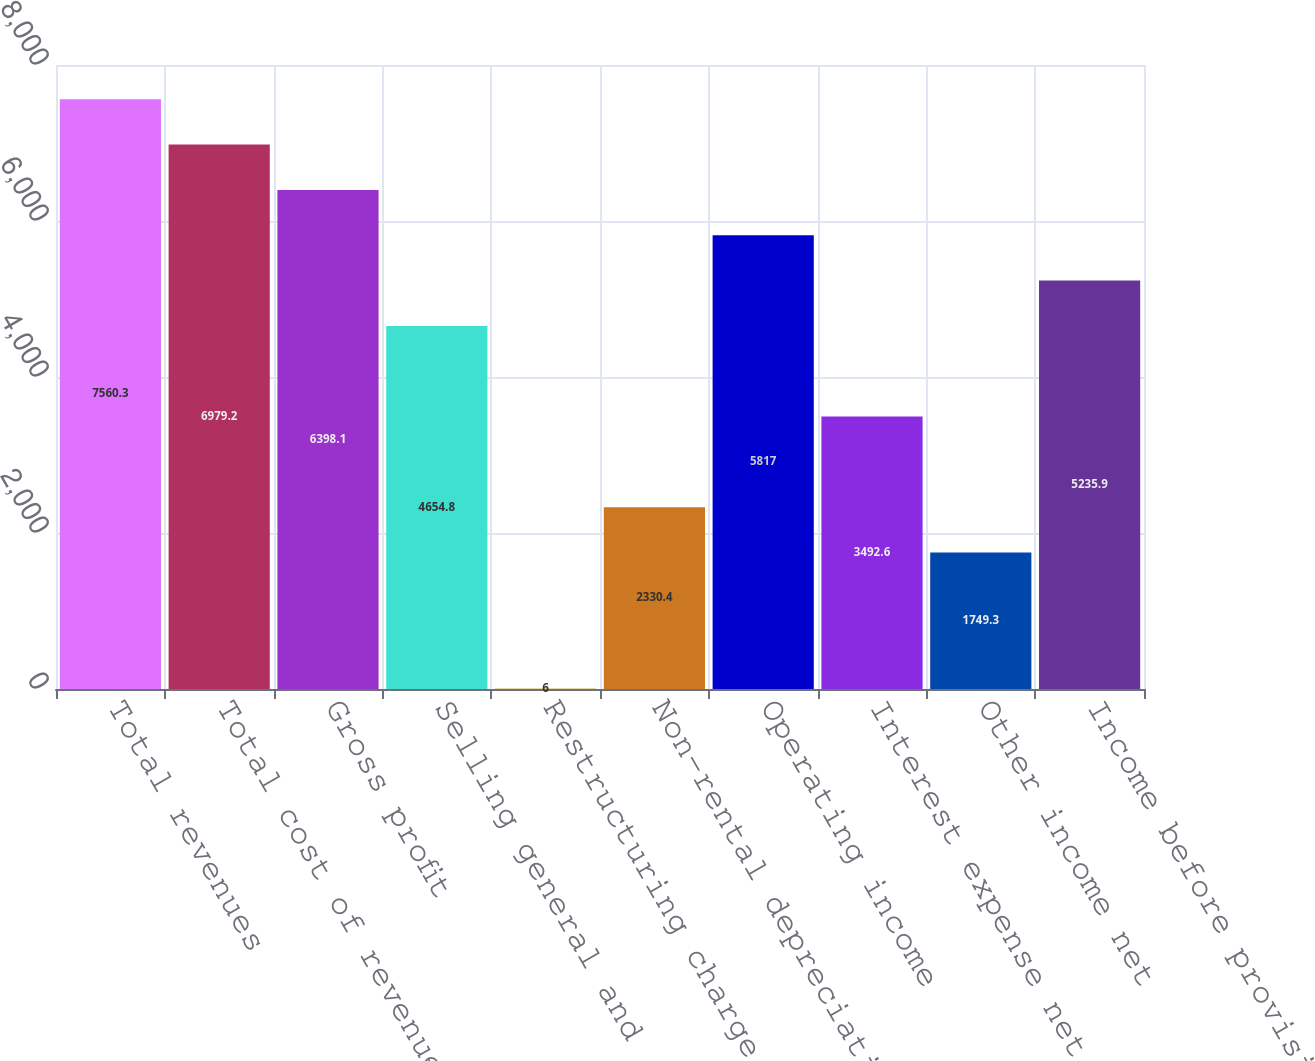Convert chart to OTSL. <chart><loc_0><loc_0><loc_500><loc_500><bar_chart><fcel>Total revenues<fcel>Total cost of revenues<fcel>Gross profit<fcel>Selling general and<fcel>Restructuring charge<fcel>Non-rental depreciation and<fcel>Operating income<fcel>Interest expense net<fcel>Other income net<fcel>Income before provision for<nl><fcel>7560.3<fcel>6979.2<fcel>6398.1<fcel>4654.8<fcel>6<fcel>2330.4<fcel>5817<fcel>3492.6<fcel>1749.3<fcel>5235.9<nl></chart> 